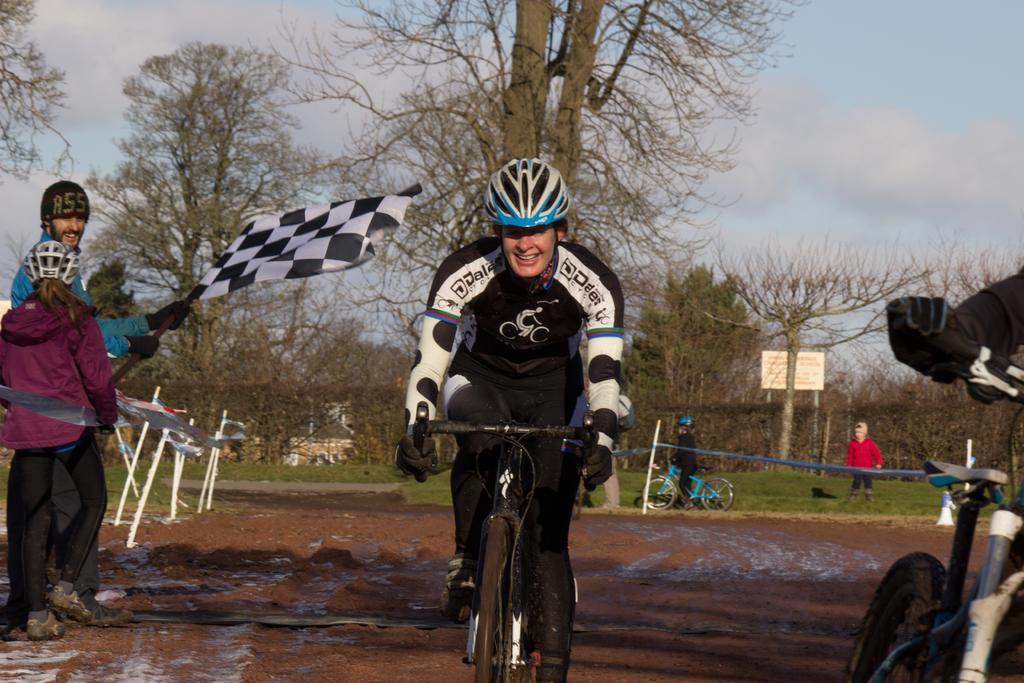Describe this image in one or two sentences. In this picture there are people, among them there is a person riding a bicycle and wore helmet. We can see flags, pole, mud and grass. In the background of the image we can see trees, board and sky. 